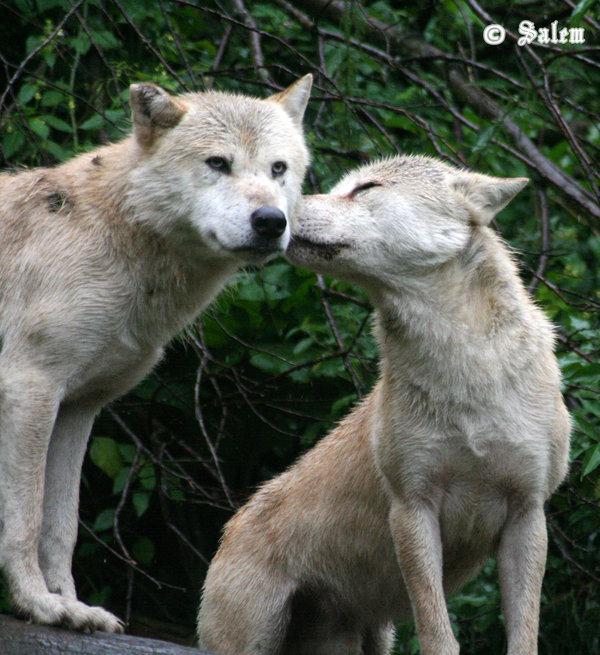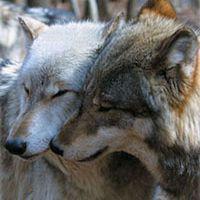The first image is the image on the left, the second image is the image on the right. Considering the images on both sides, is "You can see a wolf's tongue." valid? Answer yes or no. No. The first image is the image on the left, the second image is the image on the right. Given the left and right images, does the statement "At least one wolf is using their tongue to kiss." hold true? Answer yes or no. No. 